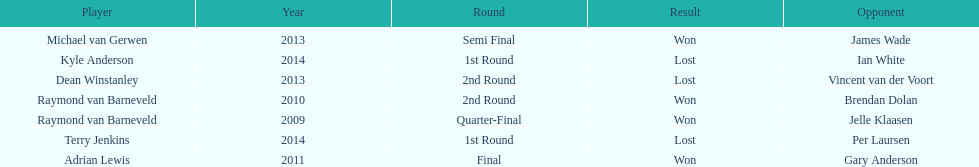How many champions were from norway? 0. 